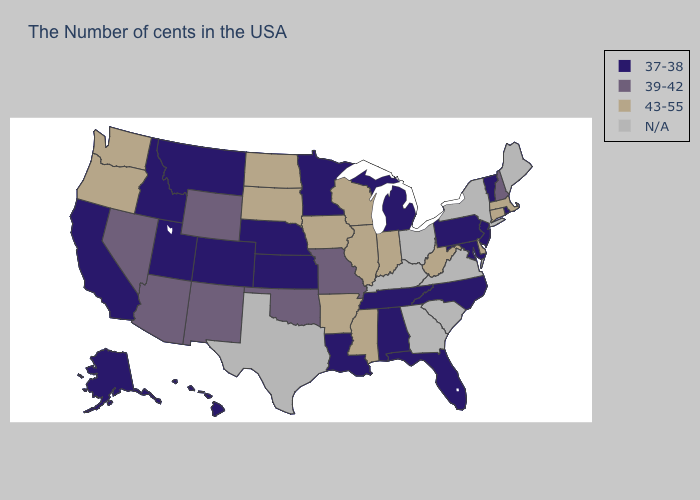What is the highest value in the Northeast ?
Short answer required. 43-55. Does Rhode Island have the lowest value in the Northeast?
Write a very short answer. Yes. Name the states that have a value in the range 43-55?
Quick response, please. Massachusetts, Connecticut, Delaware, West Virginia, Indiana, Wisconsin, Illinois, Mississippi, Arkansas, Iowa, South Dakota, North Dakota, Washington, Oregon. What is the highest value in the USA?
Give a very brief answer. 43-55. Name the states that have a value in the range 43-55?
Be succinct. Massachusetts, Connecticut, Delaware, West Virginia, Indiana, Wisconsin, Illinois, Mississippi, Arkansas, Iowa, South Dakota, North Dakota, Washington, Oregon. Name the states that have a value in the range 39-42?
Write a very short answer. New Hampshire, Missouri, Oklahoma, Wyoming, New Mexico, Arizona, Nevada. What is the value of Arizona?
Write a very short answer. 39-42. What is the value of Hawaii?
Write a very short answer. 37-38. Name the states that have a value in the range 43-55?
Answer briefly. Massachusetts, Connecticut, Delaware, West Virginia, Indiana, Wisconsin, Illinois, Mississippi, Arkansas, Iowa, South Dakota, North Dakota, Washington, Oregon. Name the states that have a value in the range 39-42?
Write a very short answer. New Hampshire, Missouri, Oklahoma, Wyoming, New Mexico, Arizona, Nevada. Which states have the lowest value in the MidWest?
Answer briefly. Michigan, Minnesota, Kansas, Nebraska. Name the states that have a value in the range 43-55?
Be succinct. Massachusetts, Connecticut, Delaware, West Virginia, Indiana, Wisconsin, Illinois, Mississippi, Arkansas, Iowa, South Dakota, North Dakota, Washington, Oregon. What is the value of Minnesota?
Give a very brief answer. 37-38. Among the states that border North Dakota , does South Dakota have the lowest value?
Quick response, please. No. 